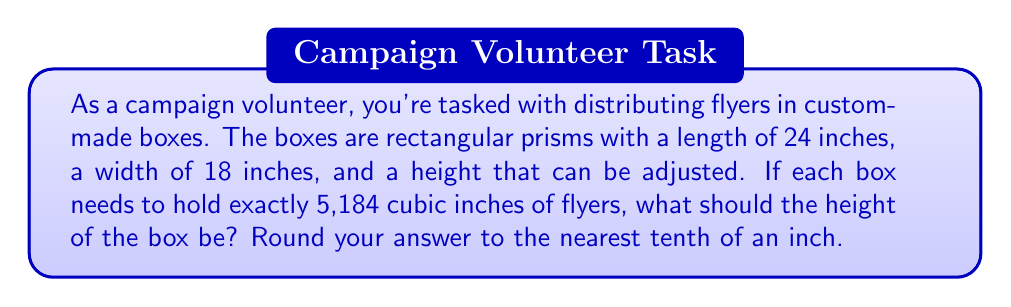Teach me how to tackle this problem. Let's approach this step-by-step:

1) The volume of a rectangular prism is given by the formula:
   $$V = l \times w \times h$$
   where $V$ is volume, $l$ is length, $w$ is width, and $h$ is height.

2) We know the following:
   - Volume (V) = 5,184 cubic inches
   - Length (l) = 24 inches
   - Width (w) = 18 inches
   - Height (h) is unknown

3) Let's substitute these values into our formula:
   $$5,184 = 24 \times 18 \times h$$

4) Simplify the right side of the equation:
   $$5,184 = 432h$$

5) To solve for h, divide both sides by 432:
   $$\frac{5,184}{432} = h$$

6) Simplify:
   $$12 = h$$

7) Therefore, the height of the box should be 12 inches.

8) Since the question asks to round to the nearest tenth of an inch, our final answer is 12.0 inches.

This height will ensure that each box can hold exactly 5,184 cubic inches of flyers, optimizing the distribution process for the campaign.
Answer: 12.0 inches 